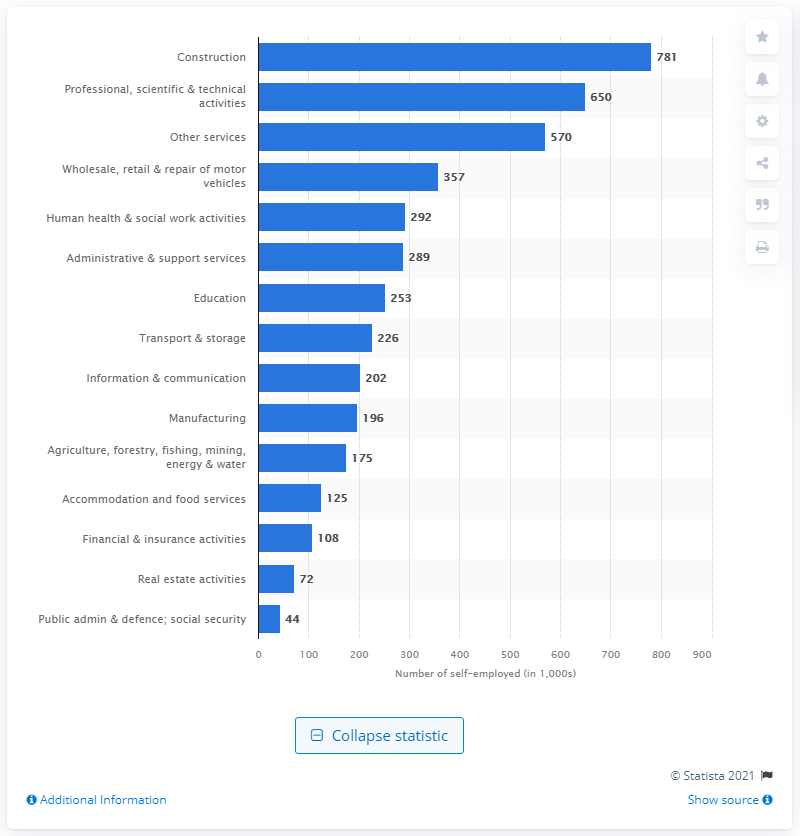Highlight a few significant elements in this photo. The second most common industry for the self-employed in the UK is construction. 